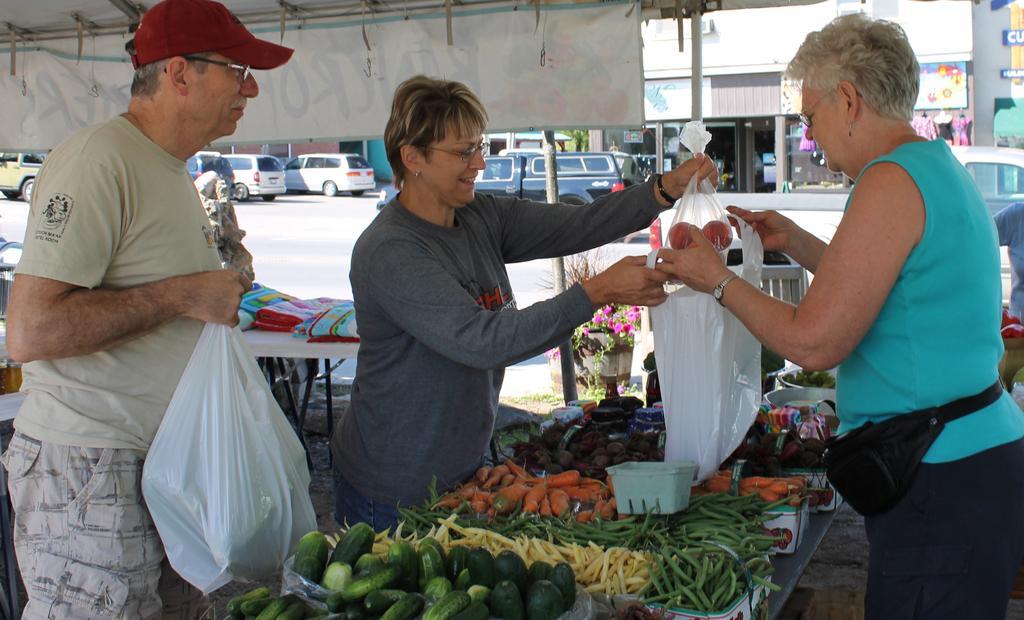How would you summarize this image in a sentence or two? In the center of the image there is a woman holding vegetables. On the right side of the image there is a woman holding a carry bag. On the left side of the image we can see a man holding vegetables. At the bottom of the image we can see vegetables. In the background we can road, vehicles and building. 